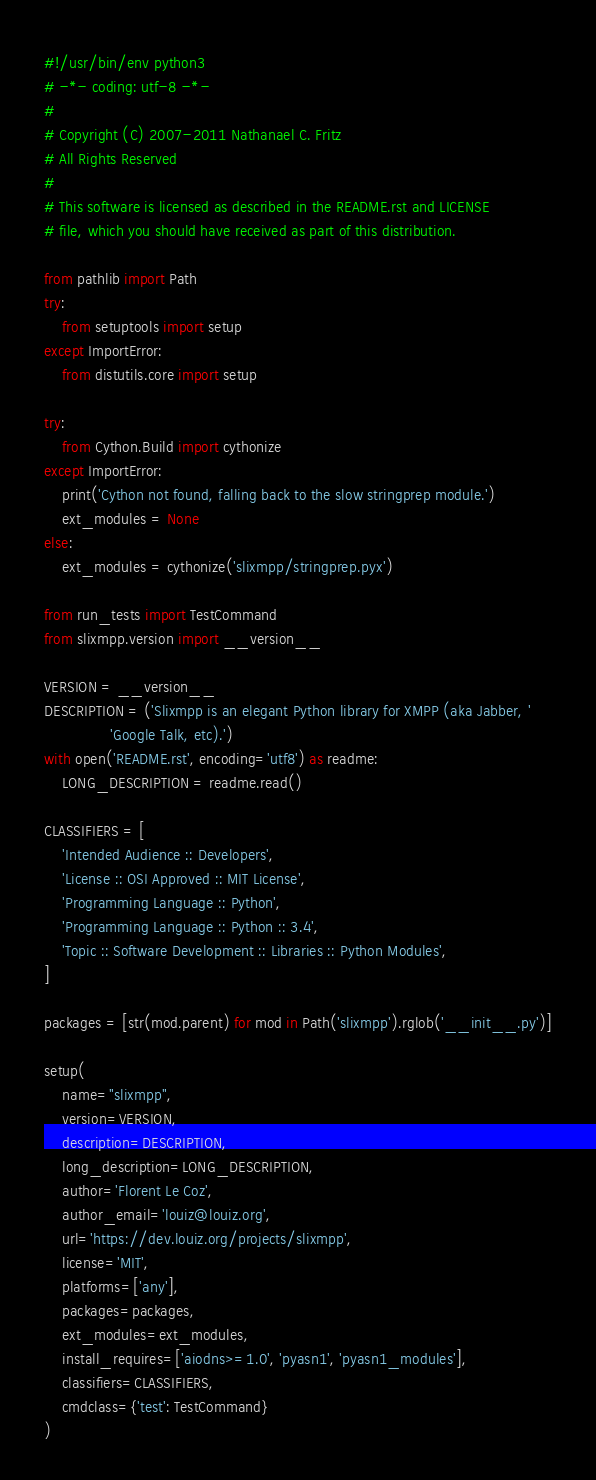<code> <loc_0><loc_0><loc_500><loc_500><_Python_>#!/usr/bin/env python3
# -*- coding: utf-8 -*-
#
# Copyright (C) 2007-2011 Nathanael C. Fritz
# All Rights Reserved
#
# This software is licensed as described in the README.rst and LICENSE
# file, which you should have received as part of this distribution.

from pathlib import Path
try:
    from setuptools import setup
except ImportError:
    from distutils.core import setup

try:
    from Cython.Build import cythonize
except ImportError:
    print('Cython not found, falling back to the slow stringprep module.')
    ext_modules = None
else:
    ext_modules = cythonize('slixmpp/stringprep.pyx')

from run_tests import TestCommand
from slixmpp.version import __version__

VERSION = __version__
DESCRIPTION = ('Slixmpp is an elegant Python library for XMPP (aka Jabber, '
               'Google Talk, etc).')
with open('README.rst', encoding='utf8') as readme:
    LONG_DESCRIPTION = readme.read()

CLASSIFIERS = [
    'Intended Audience :: Developers',
    'License :: OSI Approved :: MIT License',
    'Programming Language :: Python',
    'Programming Language :: Python :: 3.4',
    'Topic :: Software Development :: Libraries :: Python Modules',
]

packages = [str(mod.parent) for mod in Path('slixmpp').rglob('__init__.py')]

setup(
    name="slixmpp",
    version=VERSION,
    description=DESCRIPTION,
    long_description=LONG_DESCRIPTION,
    author='Florent Le Coz',
    author_email='louiz@louiz.org',
    url='https://dev.louiz.org/projects/slixmpp',
    license='MIT',
    platforms=['any'],
    packages=packages,
    ext_modules=ext_modules,
    install_requires=['aiodns>=1.0', 'pyasn1', 'pyasn1_modules'],
    classifiers=CLASSIFIERS,
    cmdclass={'test': TestCommand}
)
</code> 